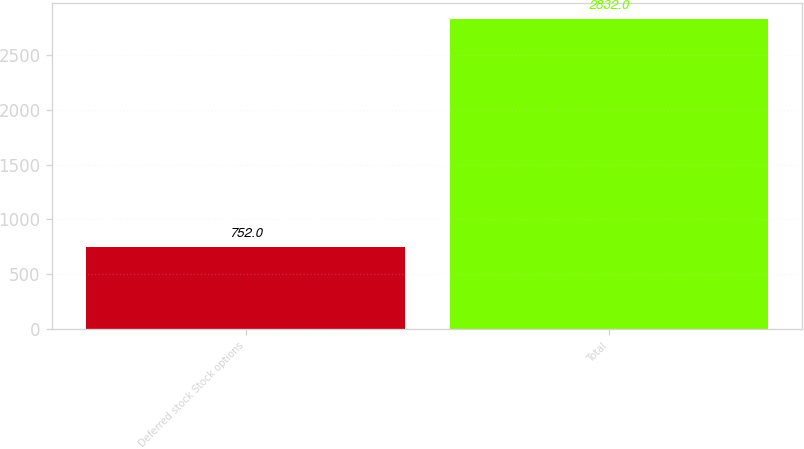<chart> <loc_0><loc_0><loc_500><loc_500><bar_chart><fcel>Deferred stock Stock options<fcel>Total<nl><fcel>752<fcel>2832<nl></chart> 